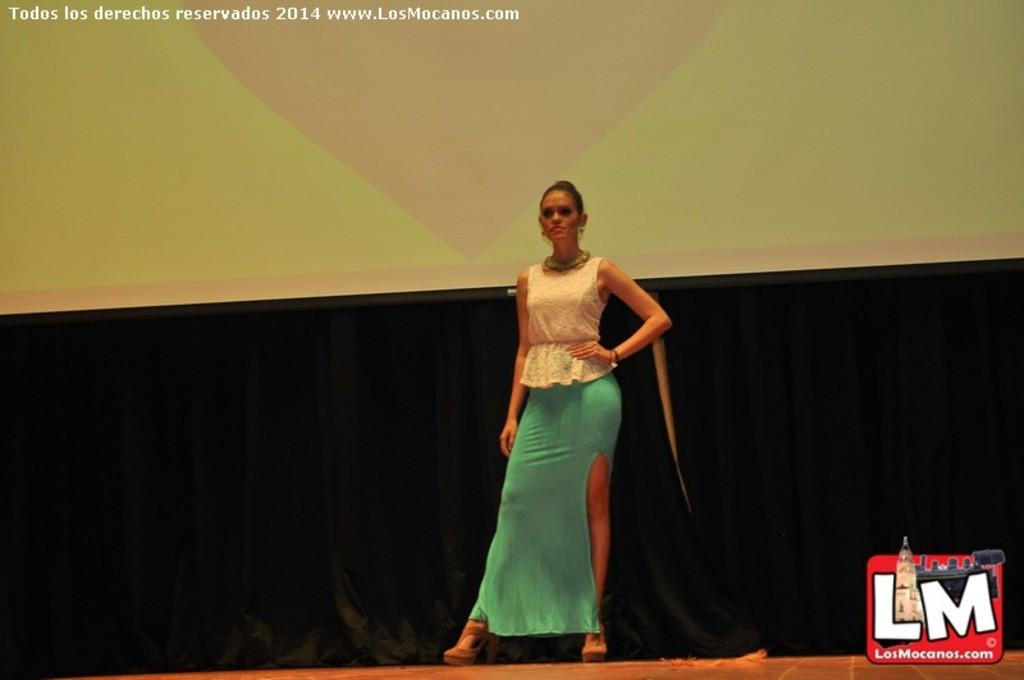What is the main subject of the image? There is a woman standing in the image. What can be seen in the background of the image? There is a screen and curtains in the background of the image. Are there any additional features or characteristics of the image? Yes, the image has watermarks. How many bells are hanging from the sock in the image? There is no sock or bell present in the image. What type of houses are visible in the background of the image? There are no houses visible in the image; it only features a woman, a screen, and curtains in the background. 